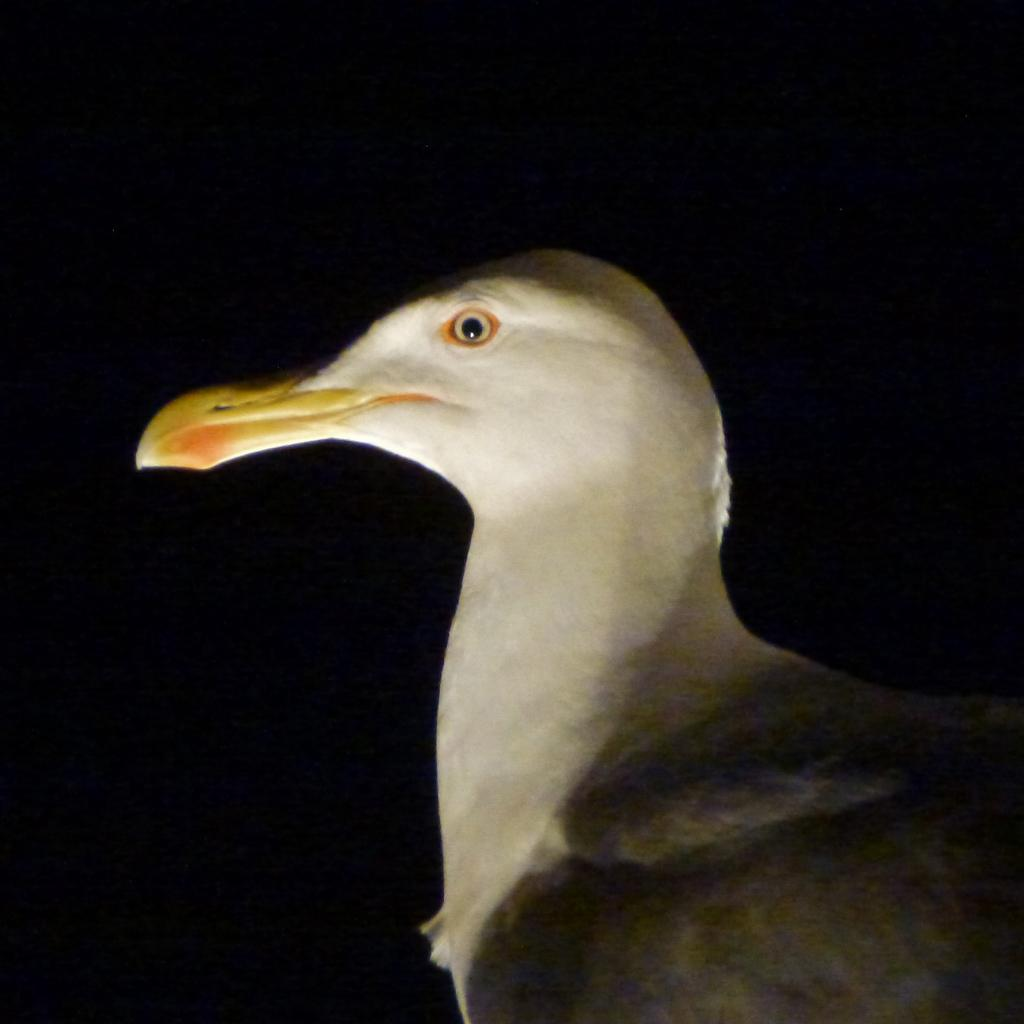What type of animal is present in the image? There is a bird in the image. What is the color of the background in the image? The background of the image is dark. What type of humor can be seen in the image? There is no humor present in the image; it features a bird against a dark background. Is there a hose visible in the image? There is no hose present in the image. Can you hear the bird coughing in the image? The image is silent, and there is no indication of a cough or any sound. 